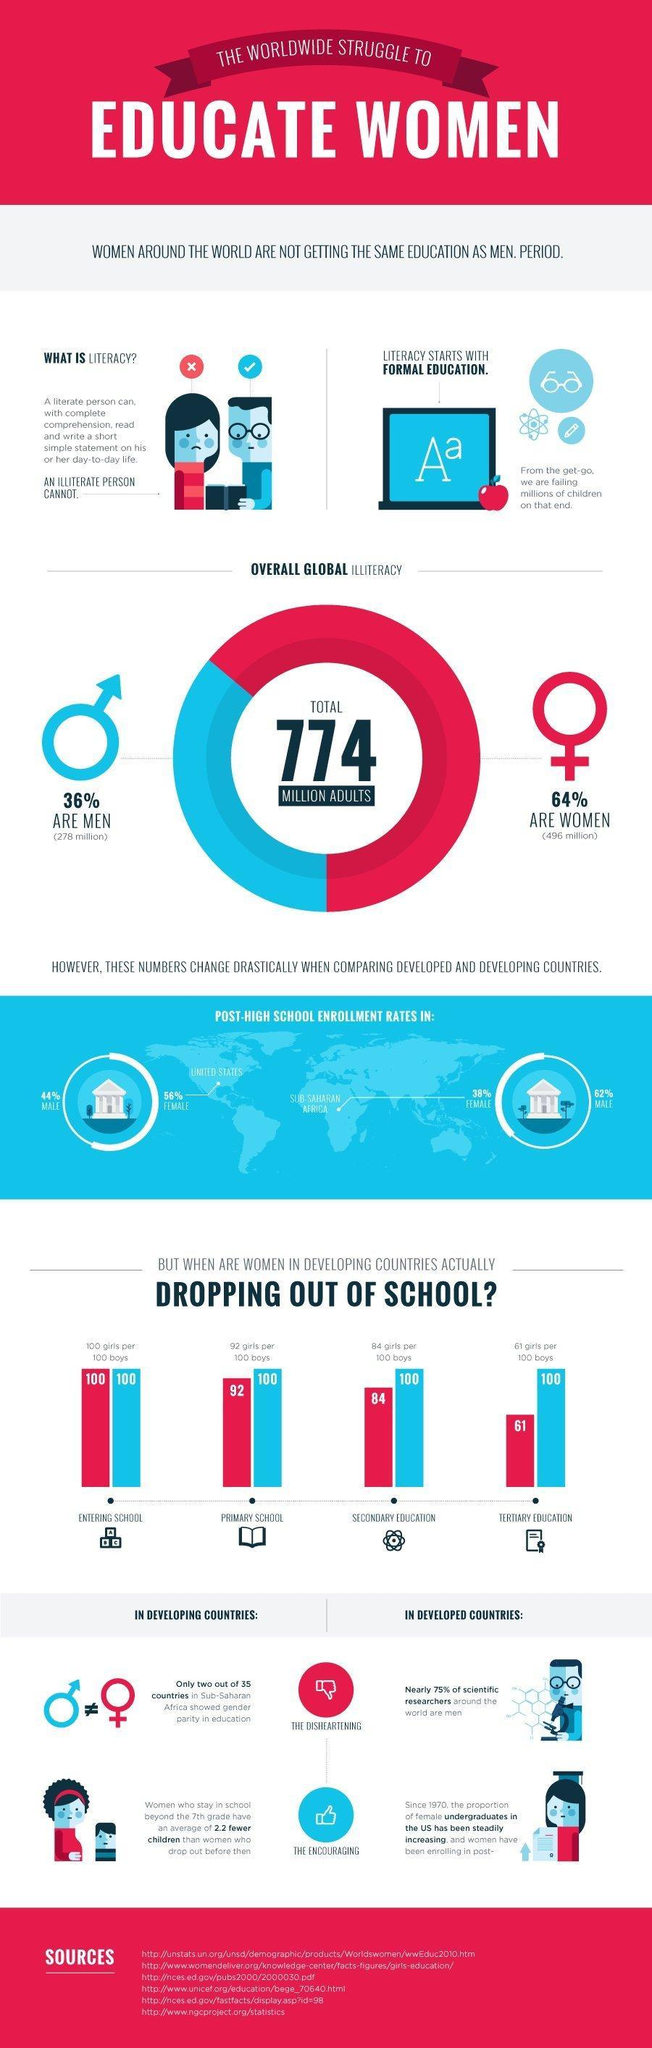What is the percentage difference in post high school enrollment rates among males in the  U.S and Sub Saharan Africa?
Answer the question with a short phrase. 18% What is the number in hundred girls that drop out of tertiary education? 39 How many girls in a number of 100 girls drop out of primary school ? 8 What percentage women are literate? 36% What is the number in hundred girls that drop out of secondary education? 16 What percentage of men are literate? 64% During which stage of education is the number of girls and boys are equal, primary school, tertiary education, or entering school? entering school What is the percentage difference in post high school enrollment rates among females in the U.S and Sub Saharan Africa? 18% 